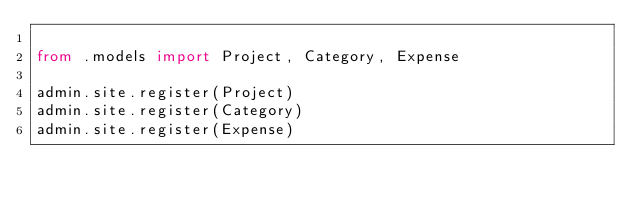<code> <loc_0><loc_0><loc_500><loc_500><_Python_>
from .models import Project, Category, Expense

admin.site.register(Project)
admin.site.register(Category)
admin.site.register(Expense)
</code> 